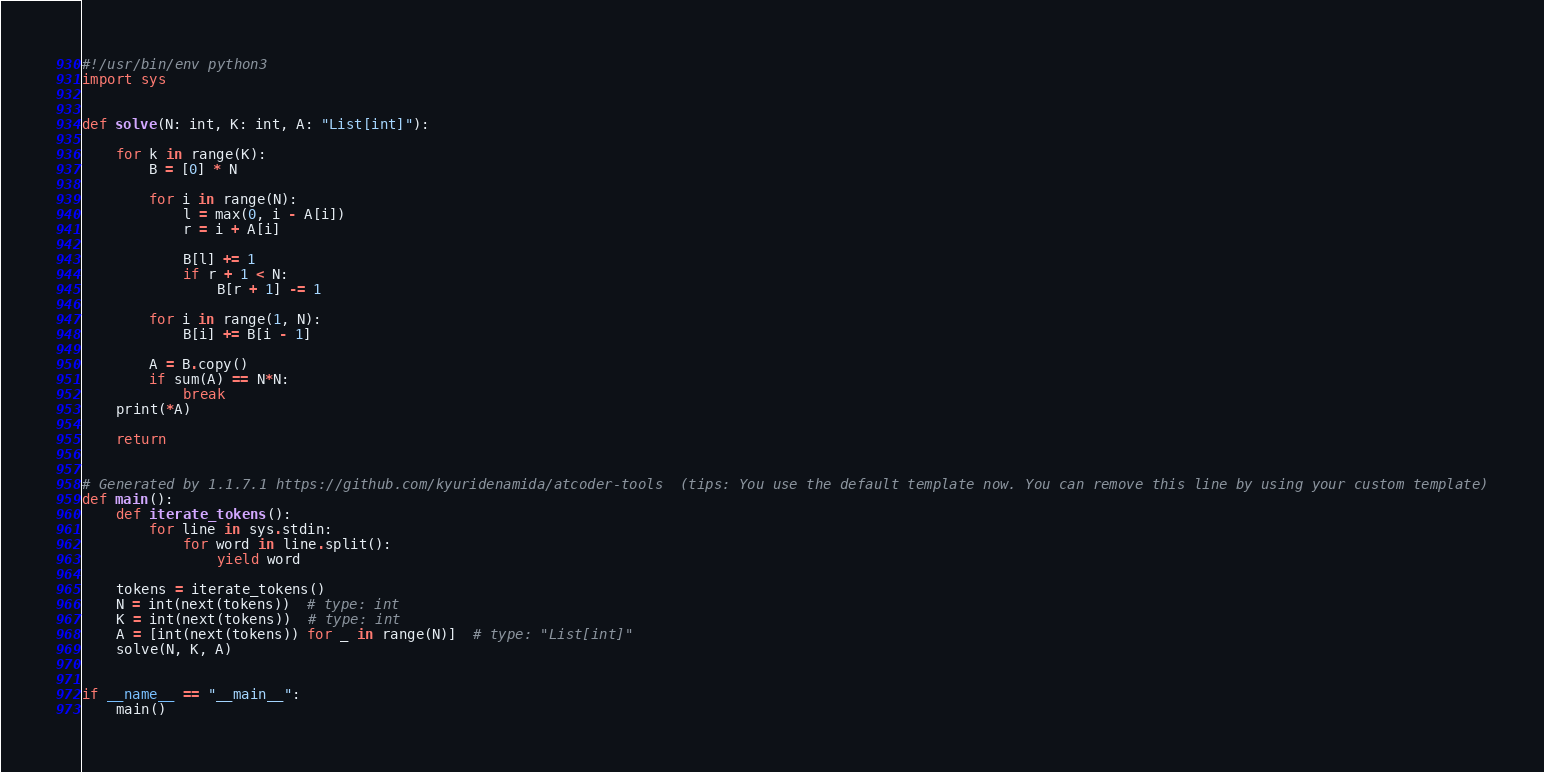<code> <loc_0><loc_0><loc_500><loc_500><_Python_>#!/usr/bin/env python3
import sys


def solve(N: int, K: int, A: "List[int]"):

    for k in range(K):
        B = [0] * N

        for i in range(N):
            l = max(0, i - A[i])
            r = i + A[i]

            B[l] += 1
            if r + 1 < N:
                B[r + 1] -= 1

        for i in range(1, N):
            B[i] += B[i - 1]

        A = B.copy()
        if sum(A) == N*N:
            break
    print(*A)

    return


# Generated by 1.1.7.1 https://github.com/kyuridenamida/atcoder-tools  (tips: You use the default template now. You can remove this line by using your custom template)
def main():
    def iterate_tokens():
        for line in sys.stdin:
            for word in line.split():
                yield word

    tokens = iterate_tokens()
    N = int(next(tokens))  # type: int
    K = int(next(tokens))  # type: int
    A = [int(next(tokens)) for _ in range(N)]  # type: "List[int]"
    solve(N, K, A)


if __name__ == "__main__":
    main()
</code> 